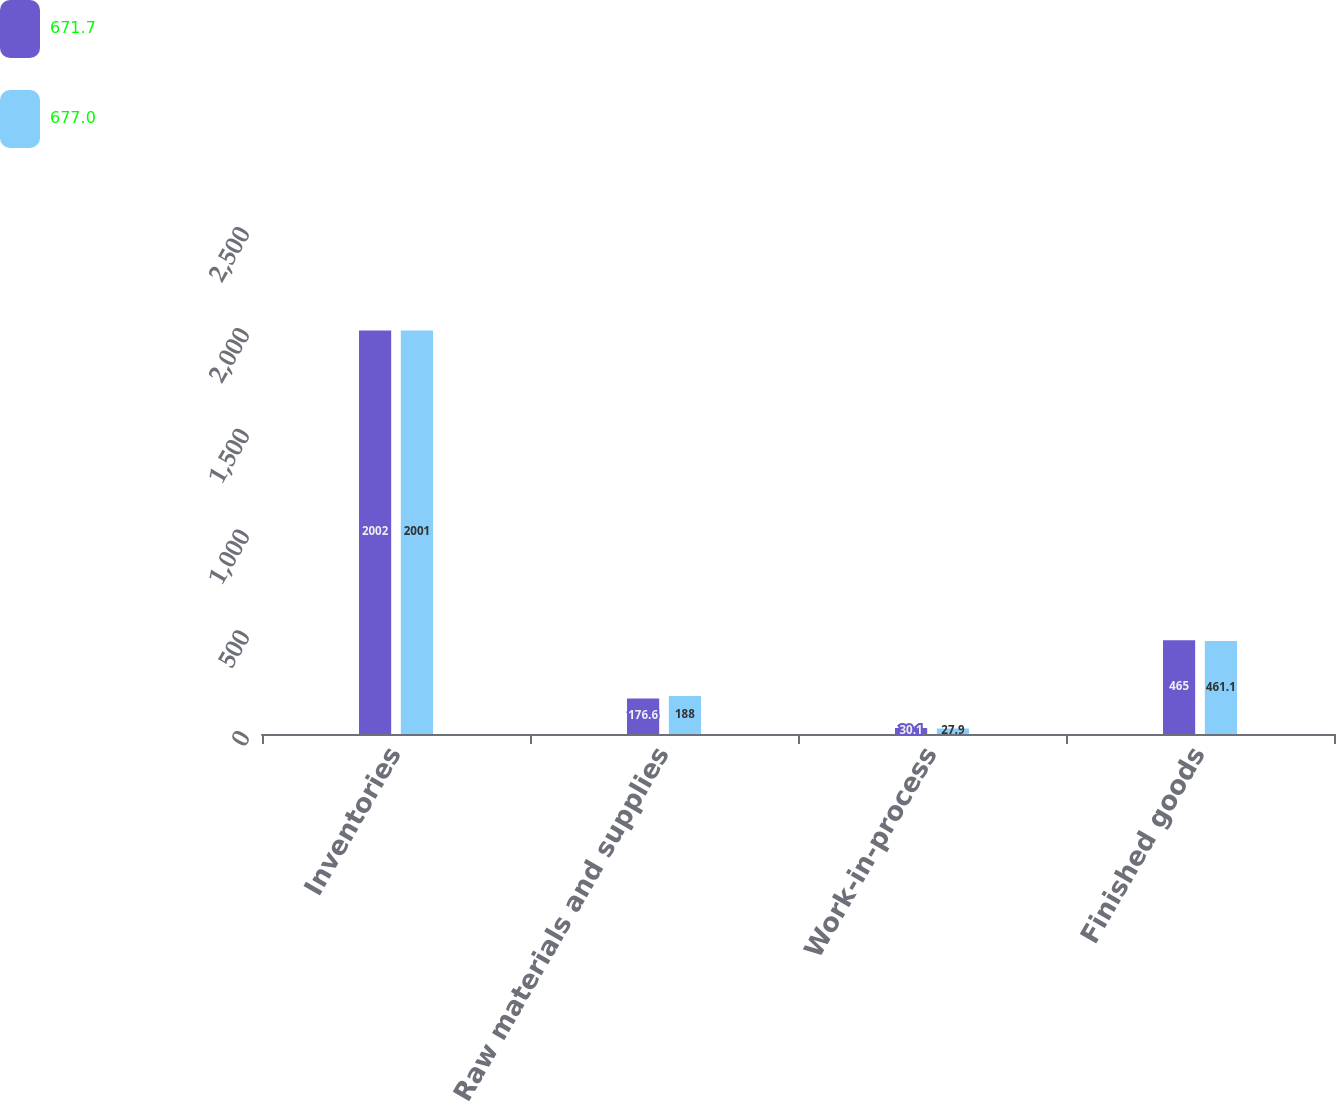<chart> <loc_0><loc_0><loc_500><loc_500><stacked_bar_chart><ecel><fcel>Inventories<fcel>Raw materials and supplies<fcel>Work-in-process<fcel>Finished goods<nl><fcel>671.7<fcel>2002<fcel>176.6<fcel>30.1<fcel>465<nl><fcel>677<fcel>2001<fcel>188<fcel>27.9<fcel>461.1<nl></chart> 